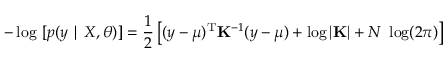Convert formula to latex. <formula><loc_0><loc_0><loc_500><loc_500>- \log \ [ p ( y | X , \theta ) ] = \frac { 1 } { 2 } \left [ ( y - \mu ) ^ { T } K ^ { - 1 } ( y - \mu ) + \log | K | + N \ \log ( 2 \pi ) \right ]</formula> 